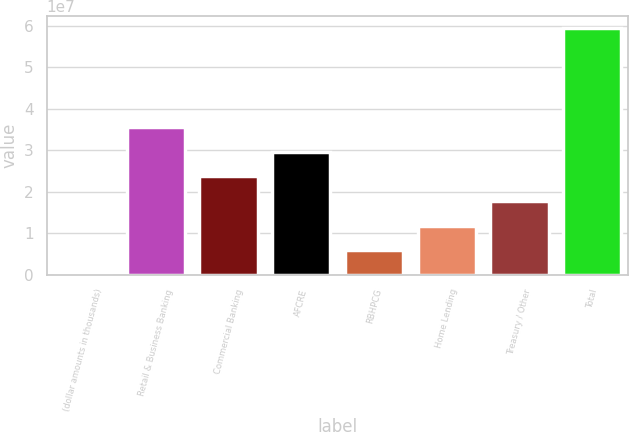Convert chart to OTSL. <chart><loc_0><loc_0><loc_500><loc_500><bar_chart><fcel>(dollar amounts in thousands)<fcel>Retail & Business Banking<fcel>Commercial Banking<fcel>AFCRE<fcel>RBHPCG<fcel>Home Lending<fcel>Treasury / Other<fcel>Total<nl><fcel>2013<fcel>3.56811e+07<fcel>2.37881e+07<fcel>2.97346e+07<fcel>5.94853e+06<fcel>1.1895e+07<fcel>1.78416e+07<fcel>5.94672e+07<nl></chart> 